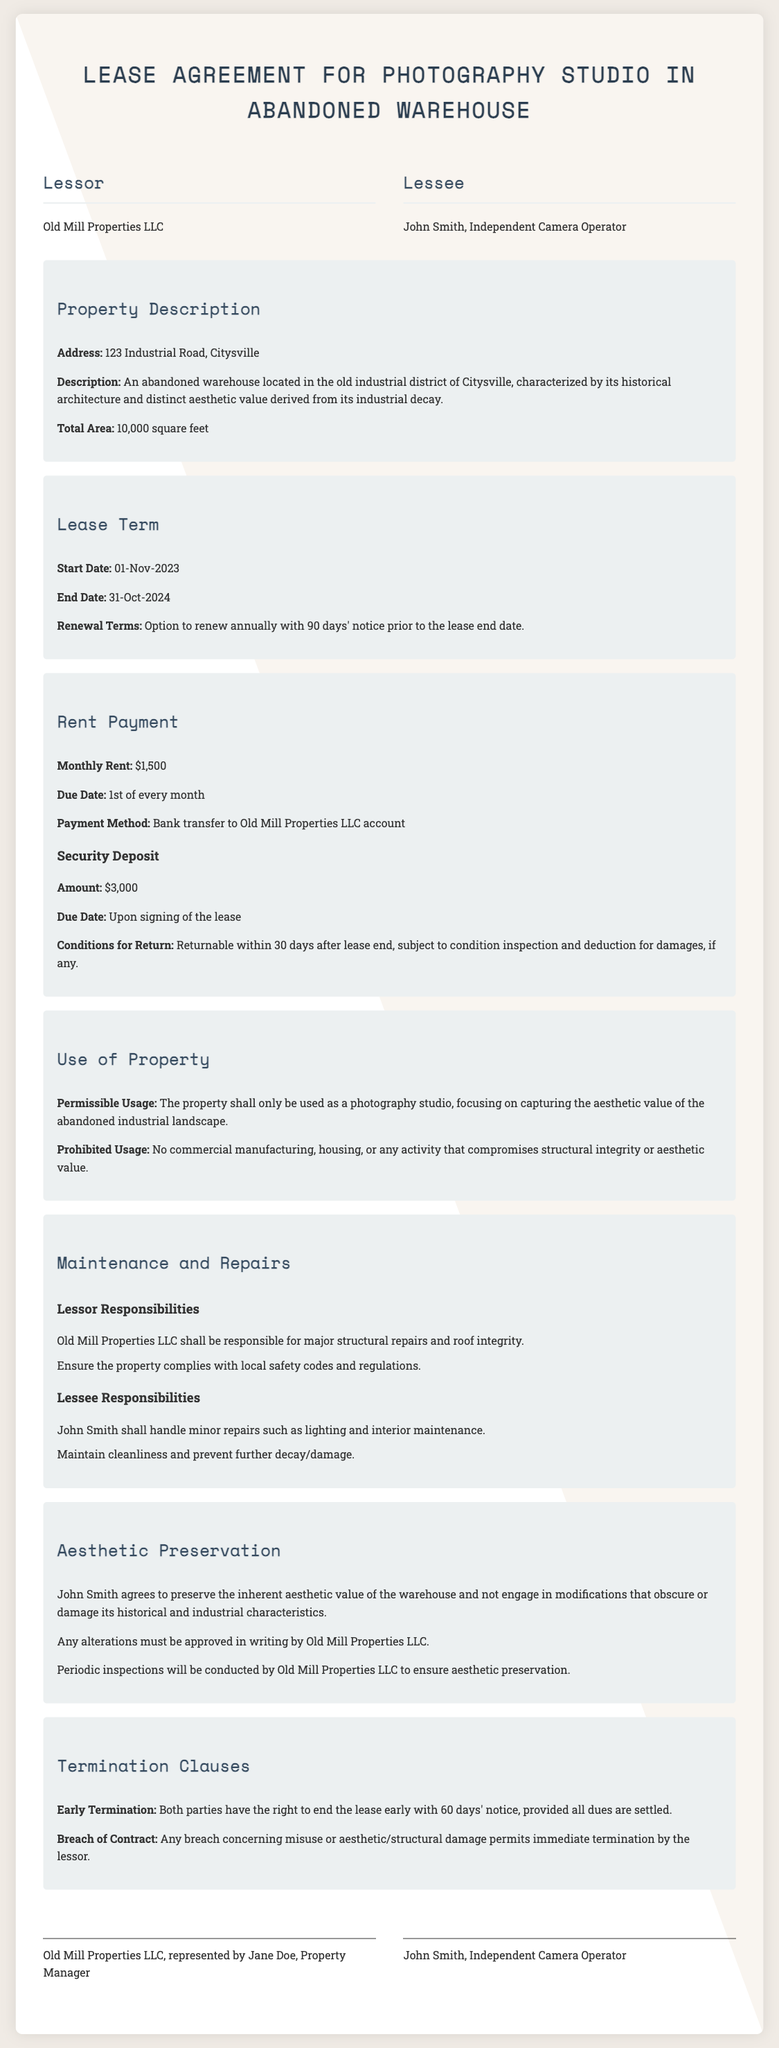What is the address of the property? The address is specified under the property details section.
Answer: 123 Industrial Road, Citysville What is the monthly rent? The lease terms section specifies the rent amount.
Answer: $1,500 What is the start date of the lease? The start date is mentioned in the lease terms section.
Answer: 01-Nov-2023 What is the lessee's responsibility regarding maintenance? Maintenance responsibilities are outlined in the maintenance section for the lessee.
Answer: Handle minor repairs such as lighting and interior maintenance What must be approved in writing by the lessor? The aesthetic preservation section mentions that certain actions require approval.
Answer: Any alterations What is the total area of the property? The property details section states the total area of the warehouse.
Answer: 10,000 square feet What happens if there is a breach of contract? The termination clauses specify consequences for breaches.
Answer: Immediate termination by the lessor What is the required notice period for early termination? The early termination clause outlines the notice requirement.
Answer: 60 days Who represents the lessor in the lease agreement? The signatures section identifies the property manager.
Answer: Jane Doe, Property Manager 